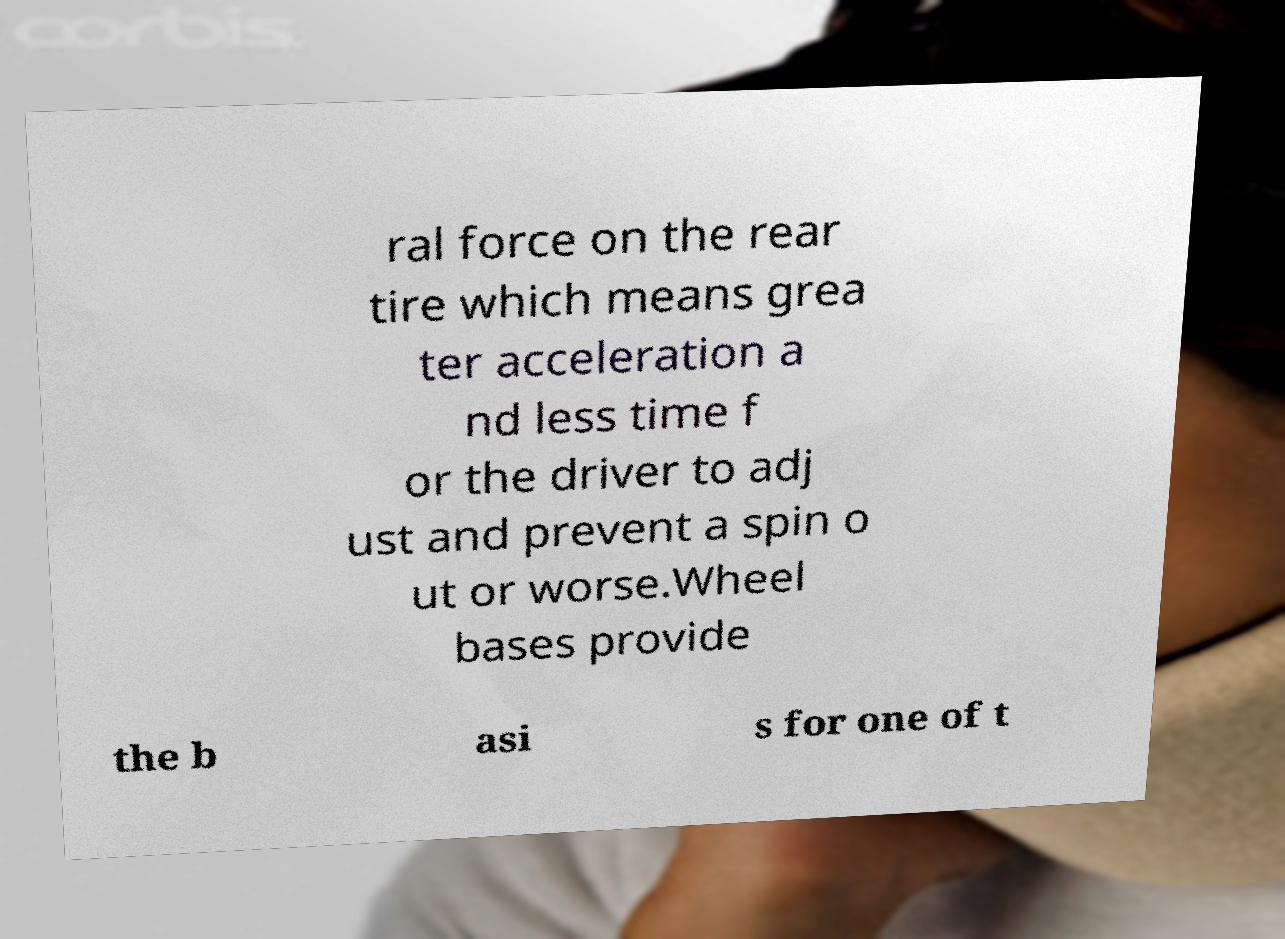For documentation purposes, I need the text within this image transcribed. Could you provide that? ral force on the rear tire which means grea ter acceleration a nd less time f or the driver to adj ust and prevent a spin o ut or worse.Wheel bases provide the b asi s for one of t 